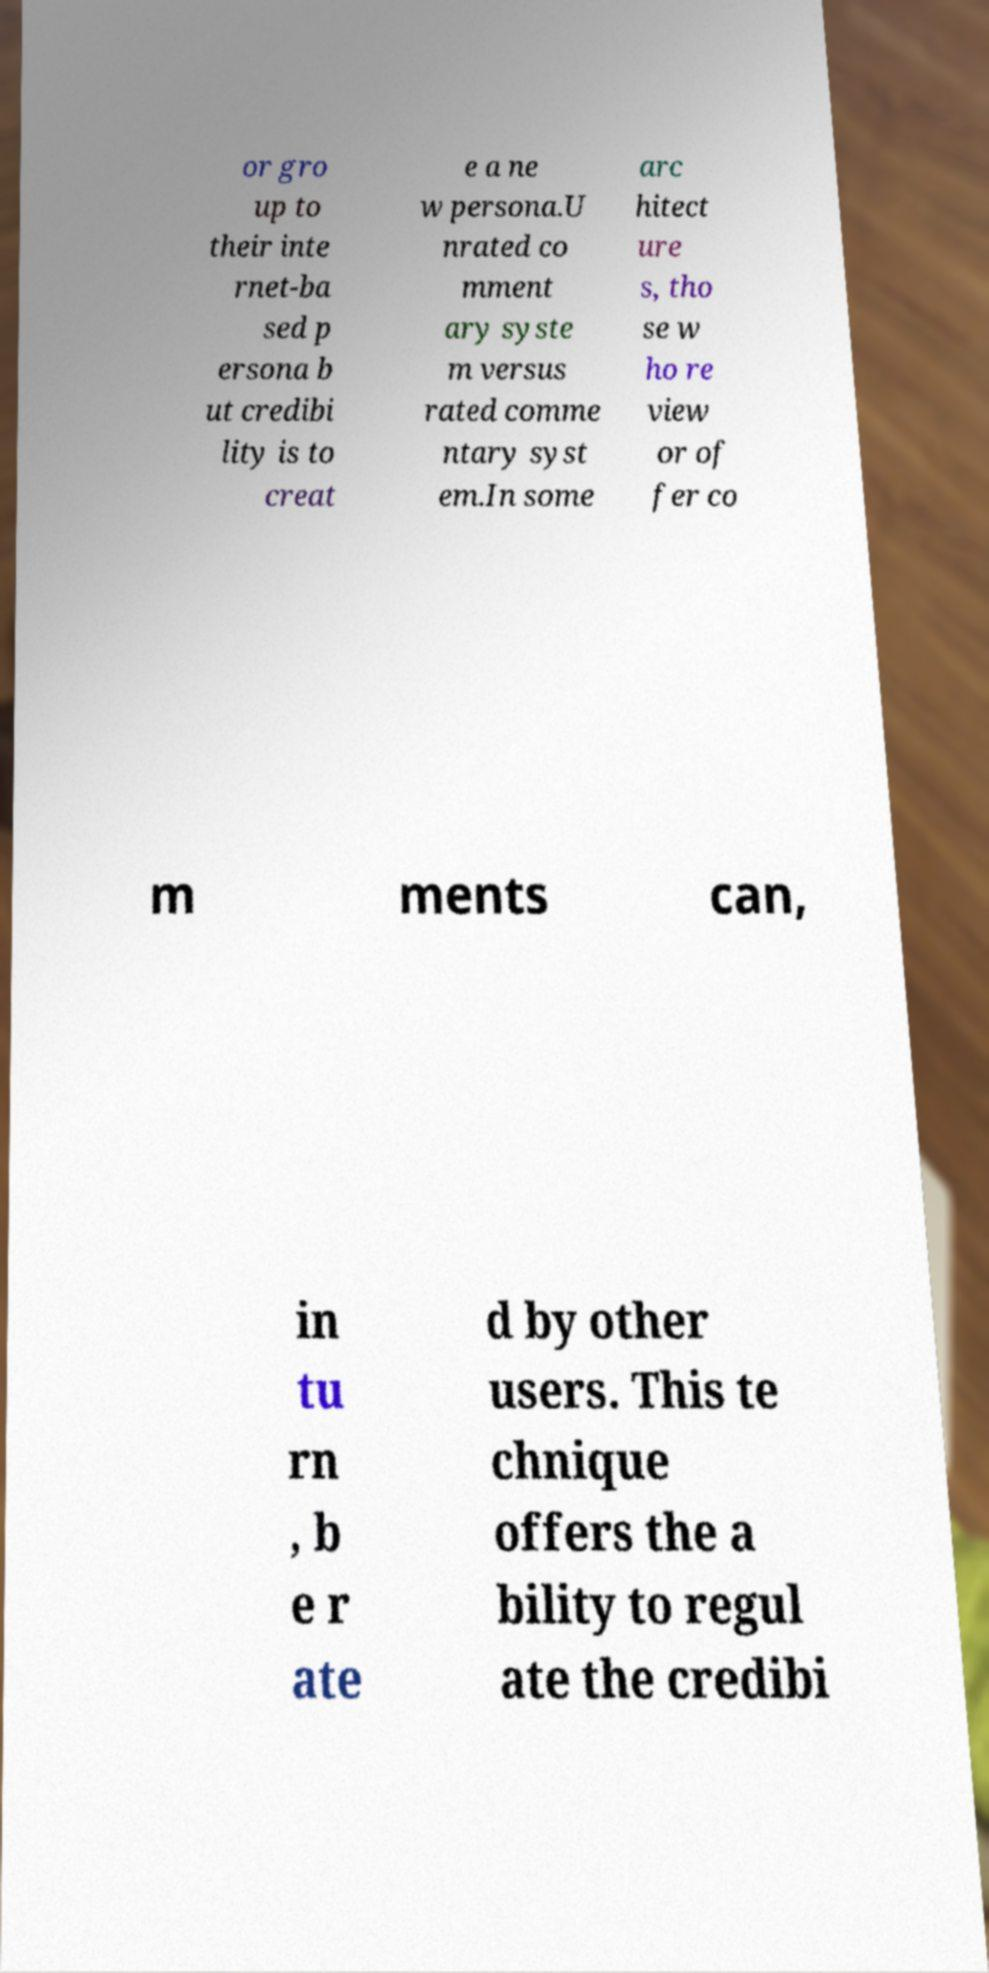Please identify and transcribe the text found in this image. or gro up to their inte rnet-ba sed p ersona b ut credibi lity is to creat e a ne w persona.U nrated co mment ary syste m versus rated comme ntary syst em.In some arc hitect ure s, tho se w ho re view or of fer co m ments can, in tu rn , b e r ate d by other users. This te chnique offers the a bility to regul ate the credibi 